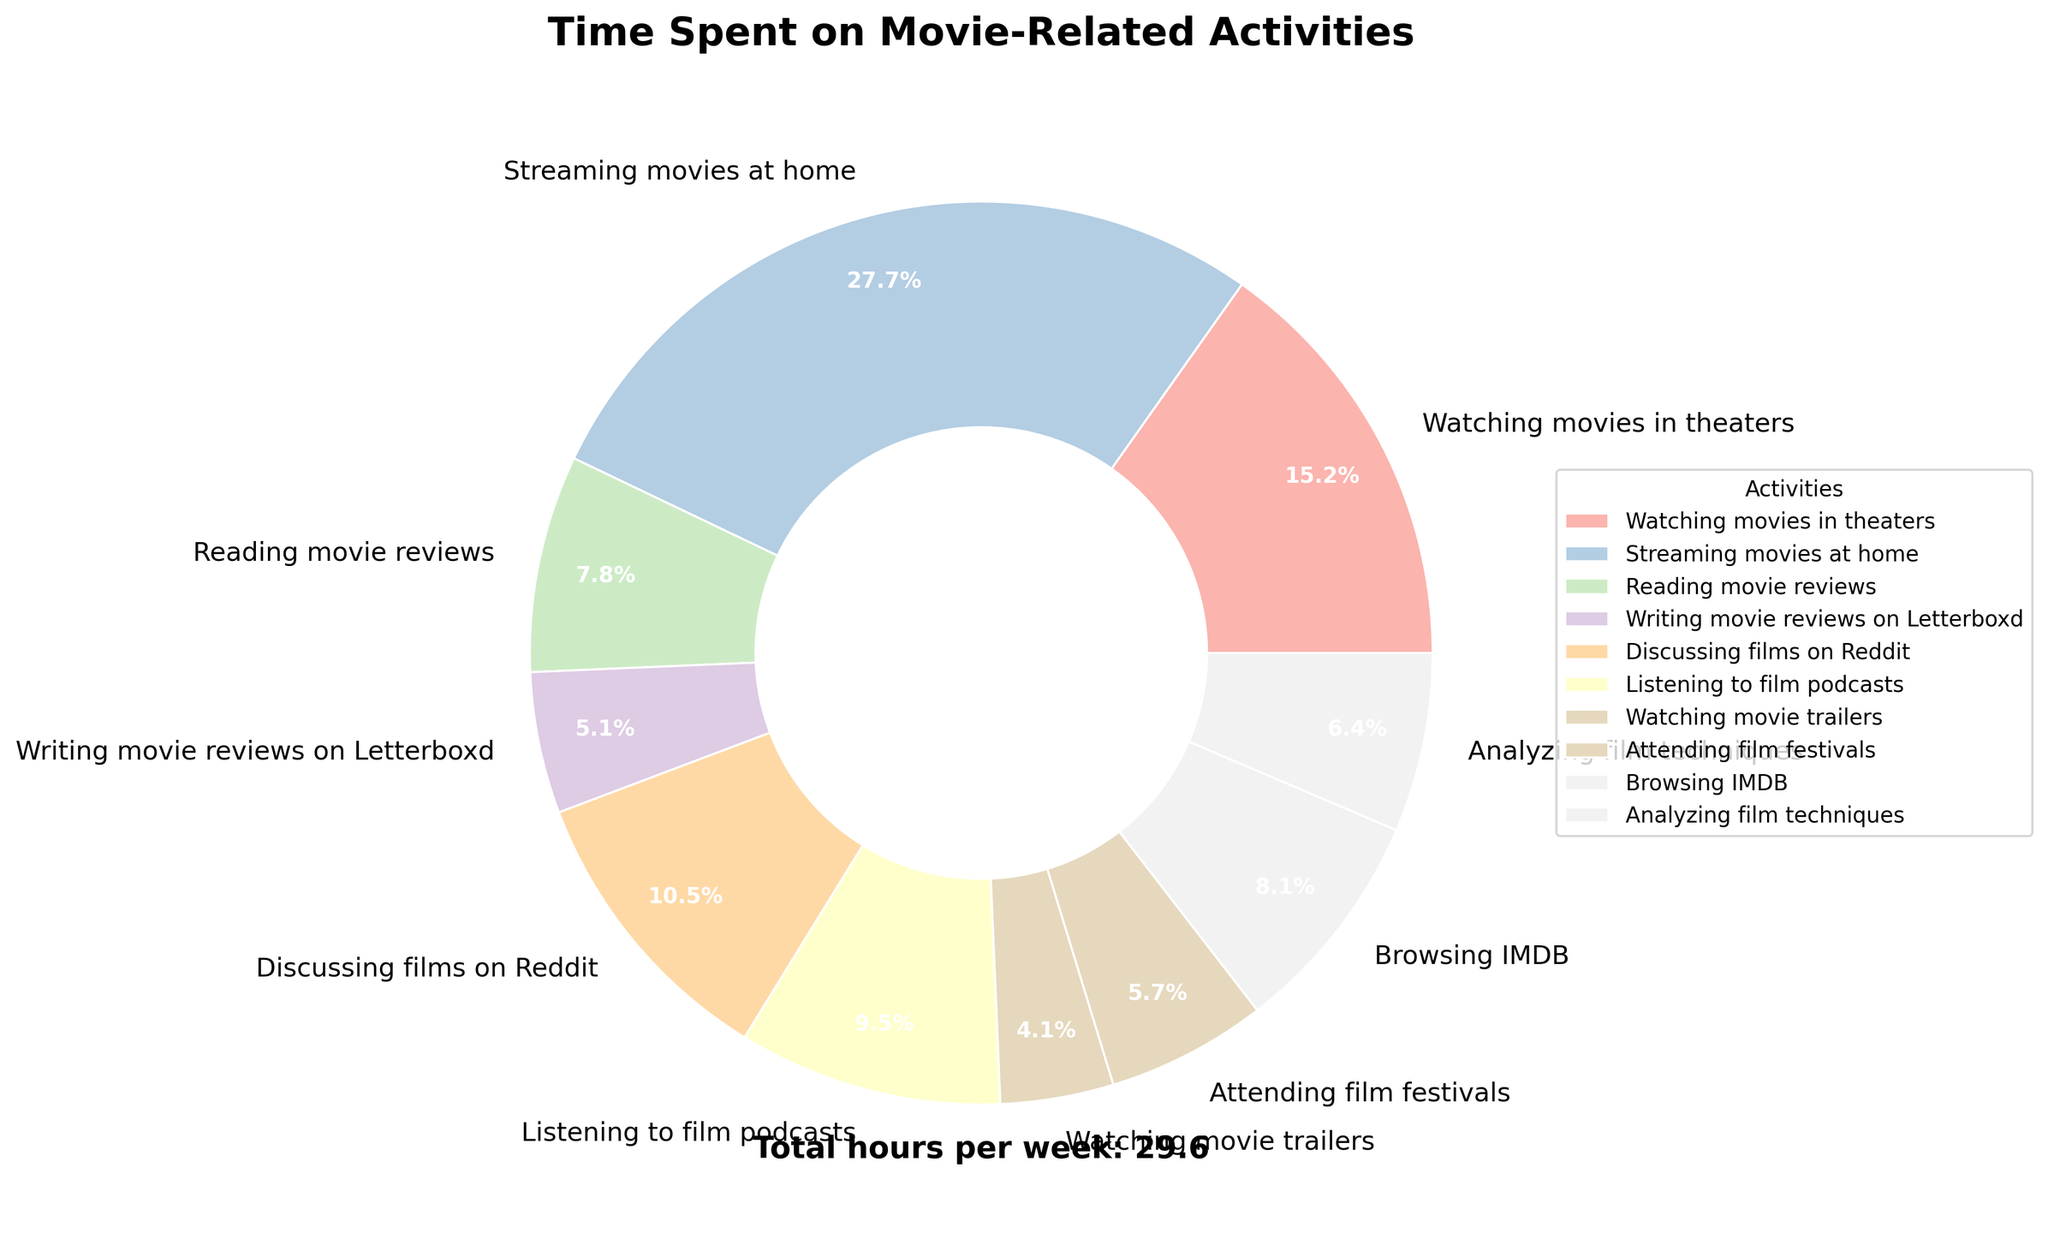What's the total time spent weekly on watching movies both in theaters and at home? To find the total time spent watching movies both in theaters and at home, add the hours spent on these two activities. Time spent watching movies in theaters is 4.5 hours, and time spent streaming movies at home is 8.2 hours. Thus, the total time is 4.5 + 8.2 = 12.7 hours.
Answer: 12.7 hours Which activity occupies the largest portion of the pie chart? The activity that occupies the largest portion of the pie chart can be visually identified by the largest wedge. This wedge corresponds to the activity "Streaming movies at home."
Answer: Streaming movies at home How much more time is spent on 'Reading movie reviews' compared to 'Watching movie trailers'? To find out how much more time is spent on reading movie reviews compared to watching movie trailers, we subtract the hours spent on watching movie trailers from the hours spent on reading movie reviews. The time spent reading movie reviews is 2.3 hours, and the time spent watching movie trailers is 1.2 hours. Therefore, 2.3 - 1.2 = 1.1 hours more are spent reading movie reviews.
Answer: 1.1 hours What percentage of the total time is spent on 'Discussing films on Reddit' and 'Listening to film podcasts' combined? First, add the hours spent on "Discussing films on Reddit" (3.1 hours) and "Listening to film podcasts" (2.8 hours) to get the combined total: 3.1 + 2.8 = 5.9 hours. Next, calculate the total time spent on all activities by summing individual times: 4.5 + 8.2 + 2.3 + 1.5 + 3.1 + 2.8 + 1.2 + 1.7 + 2.4 + 1.9 = 29.6 hours. To find the percentage, divide the combined time by the total time and multiply by 100: (5.9 / 29.6) * 100 ≈ 19.9%.
Answer: 19.9% Which activity has the smallest wedge in the pie chart, and how many hours are allocated to it? The smallest wedge in the pie chart corresponds to the activity with the least number of hours. Visually, this is identified as "Watching movie trailers," which has 1.2 hours allocated to it.
Answer: Watching movie trailers, 1.2 hours What's the difference in time between 'Browsing IMDB' and 'Attending film festivals'? Subtract the time spent attending film festivals from the time spent browsing IMDB. Browsing IMDB takes 2.4 hours, and attending film festivals takes 1.7 hours. Therefore, 2.4 - 1.7 = 0.7 hours.
Answer: 0.7 hours How many hours are spent weekly on activities that involve reading or writing? To find the total time spent on activities involving reading or writing, sum the hours from "Reading movie reviews" (2.3 hours), "Writing movie reviews on Letterboxd" (1.5 hours), and "Browsing IMDB" (2.4 hours). Therefore, the total time is 2.3 + 1.5 + 2.4 = 6.2 hours.
Answer: 6.2 hours Is more time spent on 'Listening to film podcasts' or 'Analyzing film techniques'? Compare the hours for each activity. Listening to film podcasts takes 2.8 hours, while analyzing film techniques takes 1.9 hours. Since 2.8 is greater than 1.9, more time is spent on listening to film podcasts.
Answer: Listening to film podcasts What is the average time spent on all activities per week? To find the average time spent on all activities, first calculate the total time, which is 29.6 hours. Then divide this by the number of activities, which is 10. Therefore, the average time is 29.6 / 10 = 2.96 hours.
Answer: 2.96 hours 